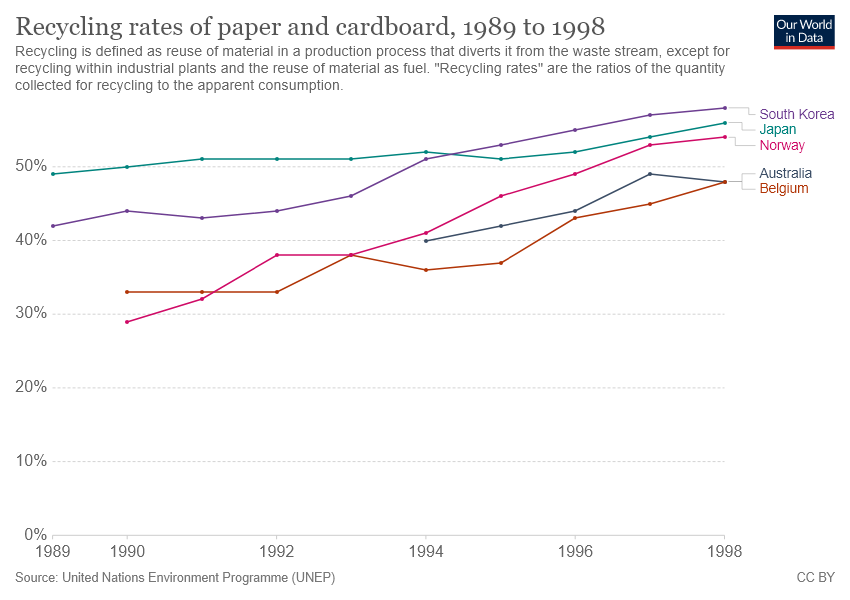Highlight a few significant elements in this photo. There are 5 lines in the graph. There are two lines whose value is between 40 and 50 percent. 